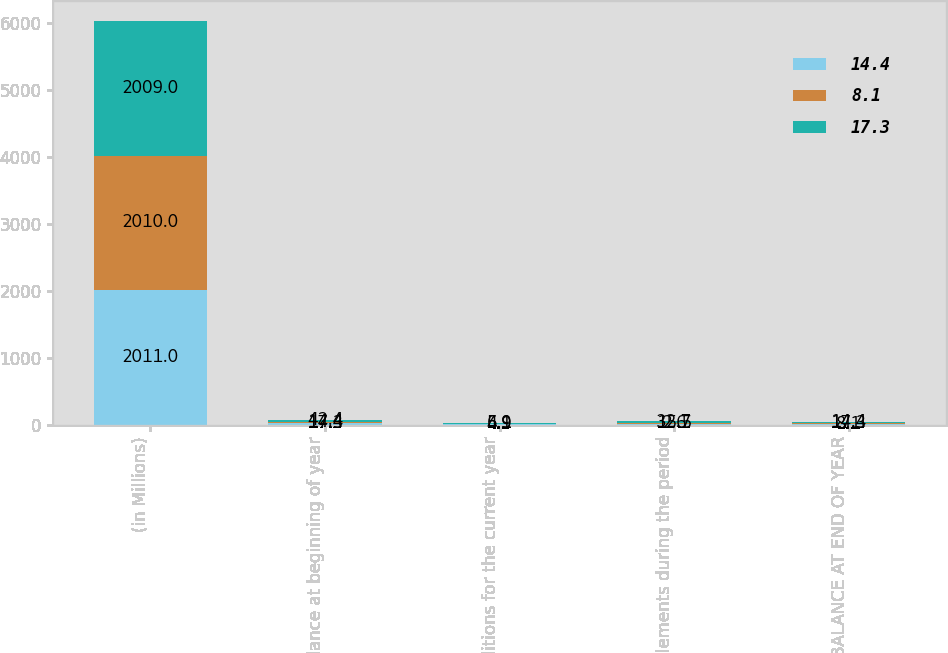Convert chart. <chart><loc_0><loc_0><loc_500><loc_500><stacked_bar_chart><ecel><fcel>(in Millions)<fcel>Balance at beginning of year<fcel>Additions for the current year<fcel>Settlements during the period<fcel>BALANCE AT END OF YEAR<nl><fcel>14.4<fcel>2011<fcel>17.3<fcel>4.9<fcel>15.5<fcel>8.1<nl><fcel>8.1<fcel>2010<fcel>14.4<fcel>6.1<fcel>2.6<fcel>17.3<nl><fcel>17.3<fcel>2009<fcel>42.4<fcel>5.9<fcel>32.7<fcel>14.4<nl></chart> 